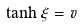<formula> <loc_0><loc_0><loc_500><loc_500>\tanh \xi = v</formula> 